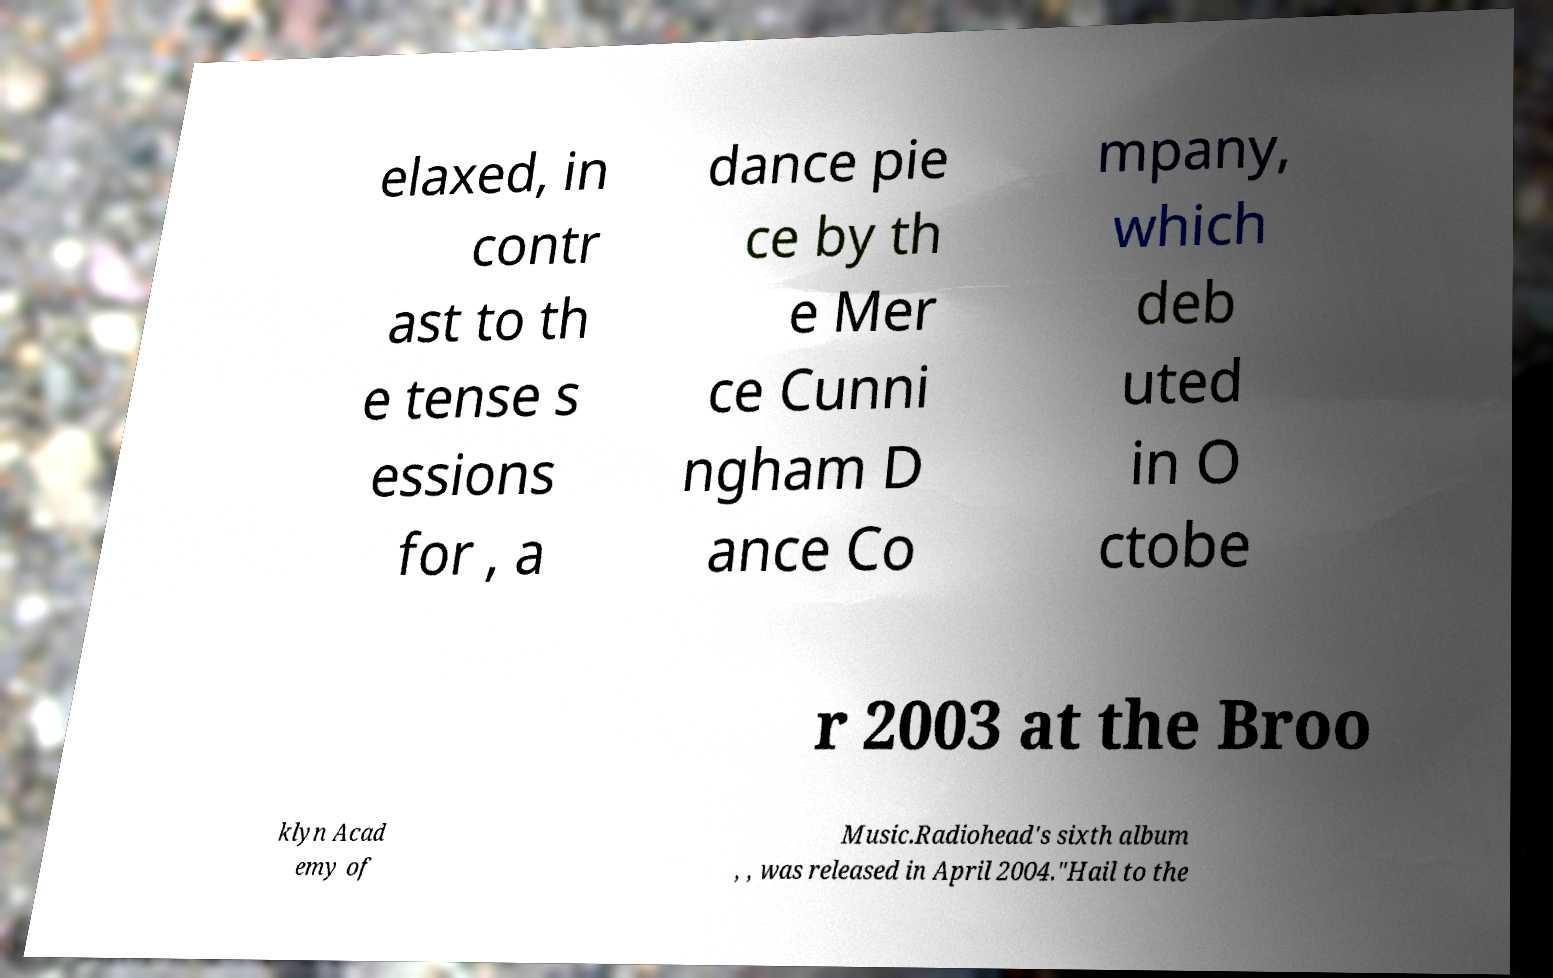For documentation purposes, I need the text within this image transcribed. Could you provide that? elaxed, in contr ast to th e tense s essions for , a dance pie ce by th e Mer ce Cunni ngham D ance Co mpany, which deb uted in O ctobe r 2003 at the Broo klyn Acad emy of Music.Radiohead's sixth album , , was released in April 2004."Hail to the 